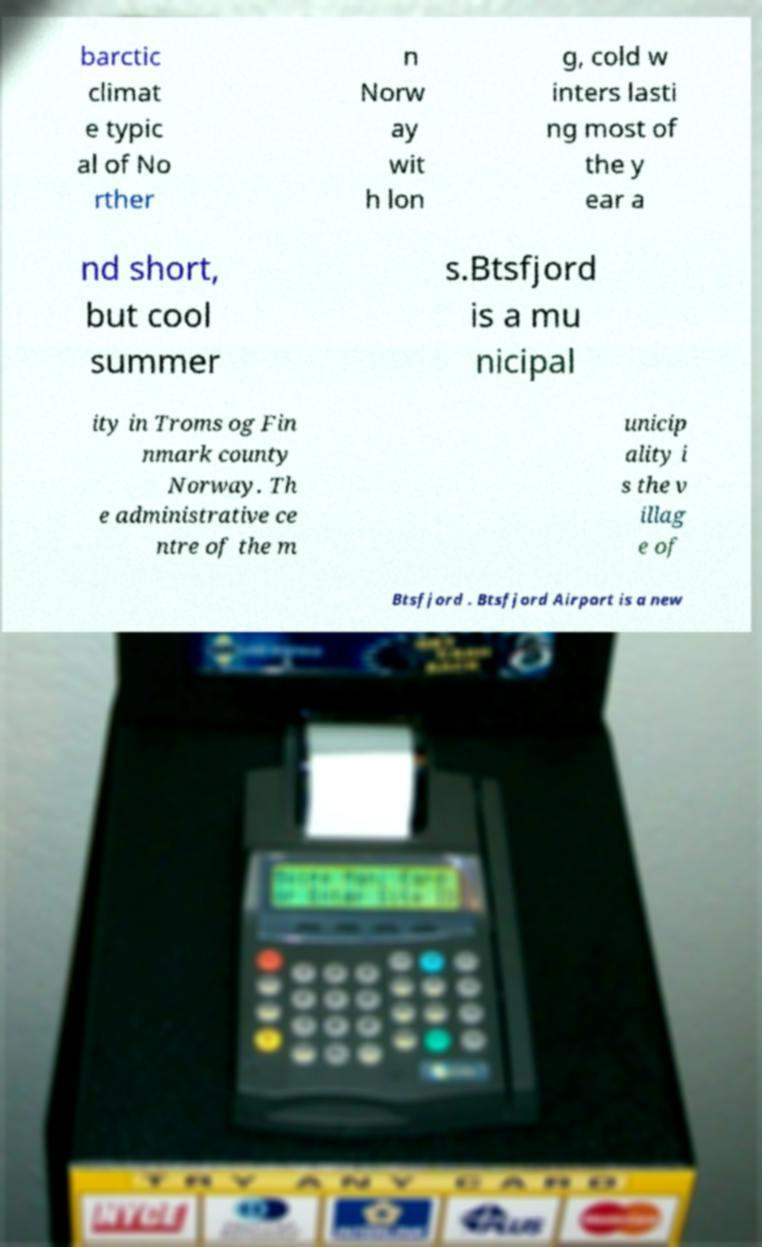I need the written content from this picture converted into text. Can you do that? barctic climat e typic al of No rther n Norw ay wit h lon g, cold w inters lasti ng most of the y ear a nd short, but cool summer s.Btsfjord is a mu nicipal ity in Troms og Fin nmark county Norway. Th e administrative ce ntre of the m unicip ality i s the v illag e of Btsfjord . Btsfjord Airport is a new 